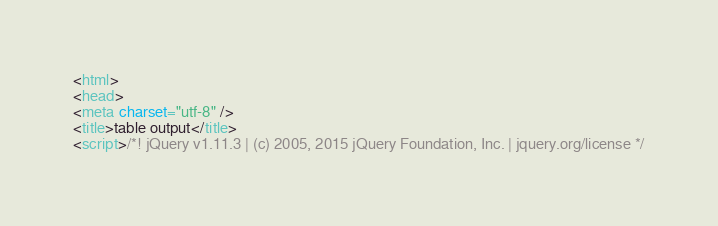Convert code to text. <code><loc_0><loc_0><loc_500><loc_500><_HTML_><html>
<head>
<meta charset="utf-8" />
<title>table output</title>
<script>/*! jQuery v1.11.3 | (c) 2005, 2015 jQuery Foundation, Inc. | jquery.org/license */</code> 